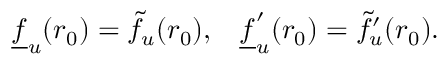<formula> <loc_0><loc_0><loc_500><loc_500>\underline { f } _ { u } ( r _ { 0 } ) = \tilde { f } _ { u } ( r _ { 0 } ) , \, \underline { f } _ { u } ^ { \prime } ( r _ { 0 } ) = \tilde { f } _ { u } ^ { \prime } ( r _ { 0 } ) .</formula> 